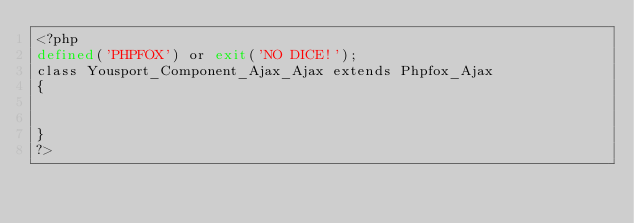Convert code to text. <code><loc_0><loc_0><loc_500><loc_500><_PHP_><?php
defined('PHPFOX') or exit('NO DICE!');     
class Yousport_Component_Ajax_Ajax extends Phpfox_Ajax
{
       
    
}  
?>
</code> 